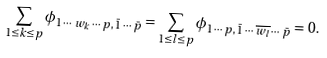<formula> <loc_0><loc_0><loc_500><loc_500>\sum _ { 1 \leq k \leq p } \phi _ { 1 \, \cdots \, w _ { k } \, \cdots \, p , \, \bar { 1 } \, \cdots \, \bar { p } } = \sum _ { 1 \leq l \leq p } \phi _ { 1 \, \cdots \, p , \, \bar { 1 } \, \cdots \, \overline { w _ { l } } \, \cdots \, \bar { p } } = 0 .</formula> 